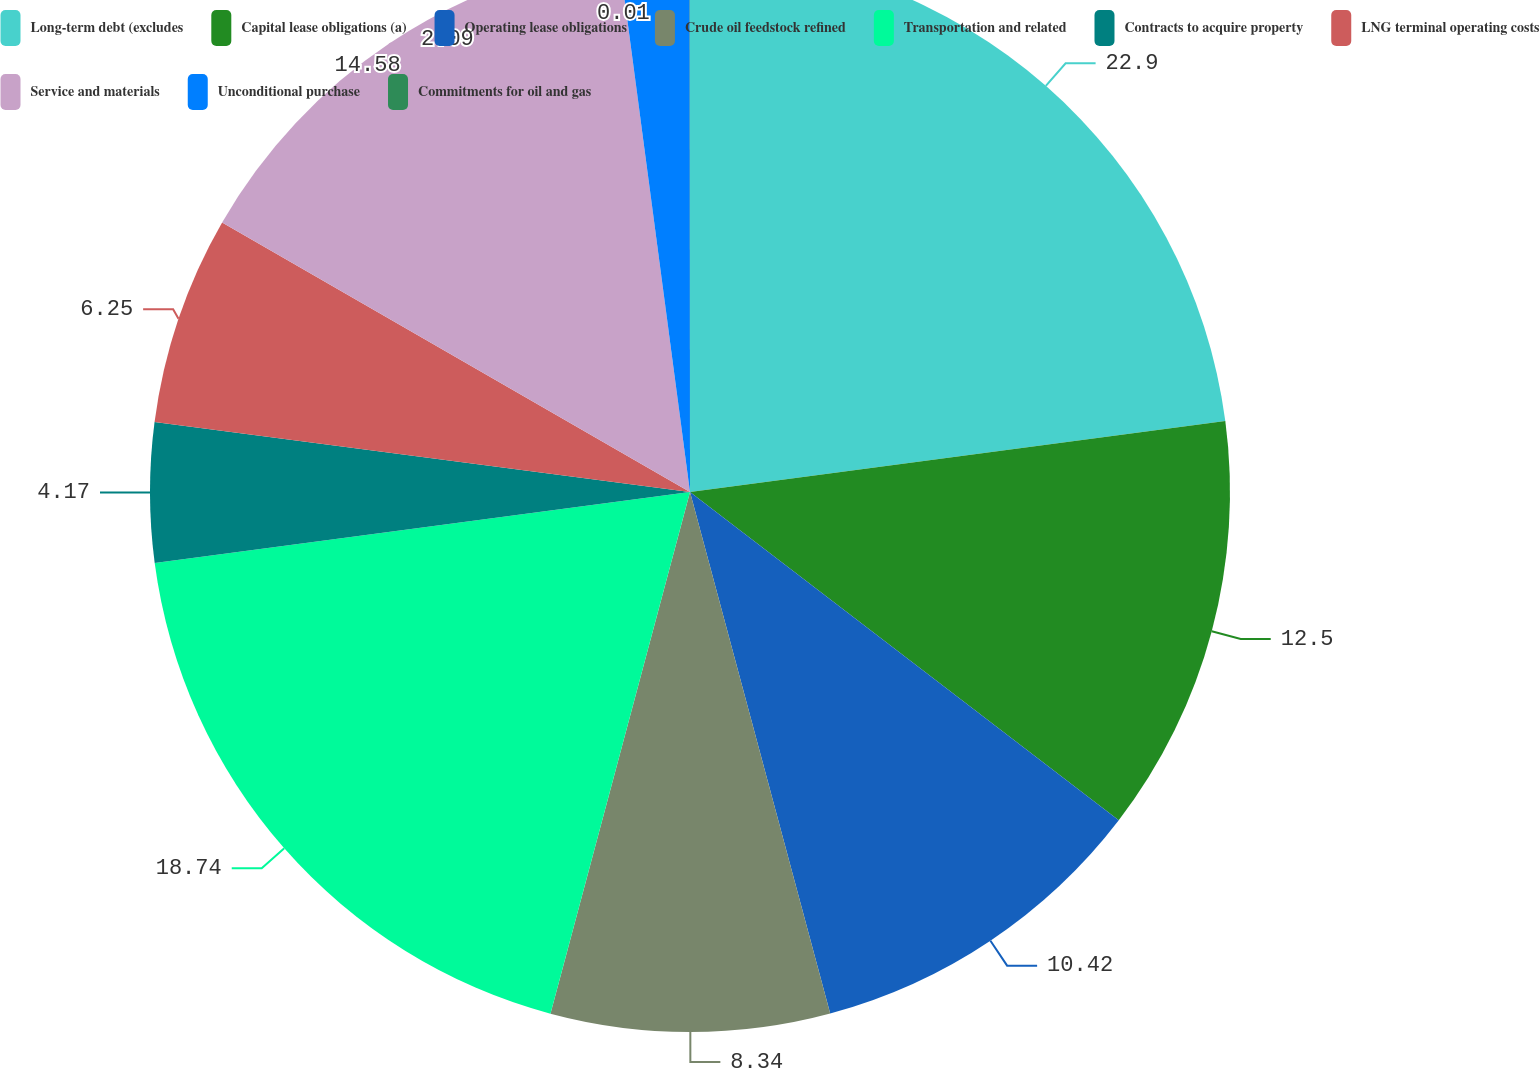<chart> <loc_0><loc_0><loc_500><loc_500><pie_chart><fcel>Long-term debt (excludes<fcel>Capital lease obligations (a)<fcel>Operating lease obligations<fcel>Crude oil feedstock refined<fcel>Transportation and related<fcel>Contracts to acquire property<fcel>LNG terminal operating costs<fcel>Service and materials<fcel>Unconditional purchase<fcel>Commitments for oil and gas<nl><fcel>22.9%<fcel>12.5%<fcel>10.42%<fcel>8.34%<fcel>18.74%<fcel>4.17%<fcel>6.25%<fcel>14.58%<fcel>2.09%<fcel>0.01%<nl></chart> 